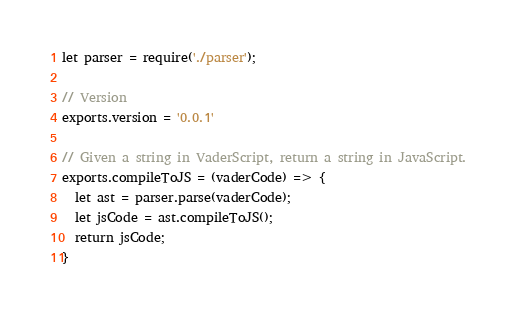Convert code to text. <code><loc_0><loc_0><loc_500><loc_500><_JavaScript_>let parser = require('./parser');

// Version
exports.version = '0.0.1'

// Given a string in VaderScript, return a string in JavaScript.
exports.compileToJS = (vaderCode) => {
  let ast = parser.parse(vaderCode);
  let jsCode = ast.compileToJS();
  return jsCode;
}</code> 